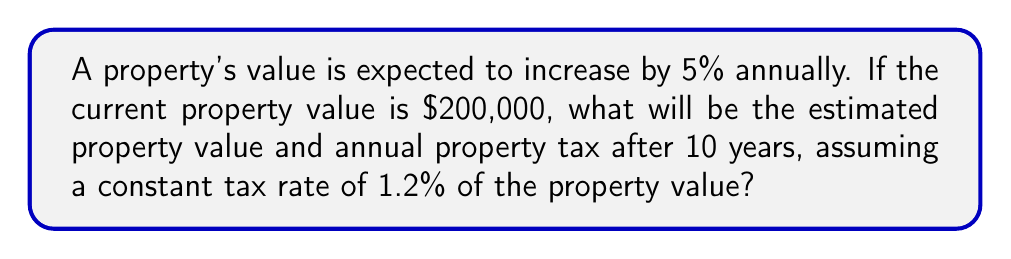Provide a solution to this math problem. Let's approach this step-by-step:

1) First, we need to calculate the future value of the property using a geometric progression:

   Initial value: $a = 200,000$
   Growth rate: $r = 1.05$ (5% increase = 1.05 times the previous value)
   Number of years: $n = 10$

   The future value formula is: $FV = a * r^n$

   $FV = 200,000 * (1.05)^{10}$

2) Let's calculate this:
   
   $FV = 200,000 * 1.6288946267$
   $FV = 325,778.93$

3) Now that we have the future property value, we can calculate the annual property tax:

   Tax rate: 1.2% = 0.012
   Annual tax = Future value * Tax rate
   
   $Annual Tax = 325,778.93 * 0.012 = 3,909.35$

Therefore, after 10 years:
- The estimated property value will be $325,778.93
- The annual property tax will be $3,909.35
Answer: Property value: $325,778.93; Annual tax: $3,909.35 